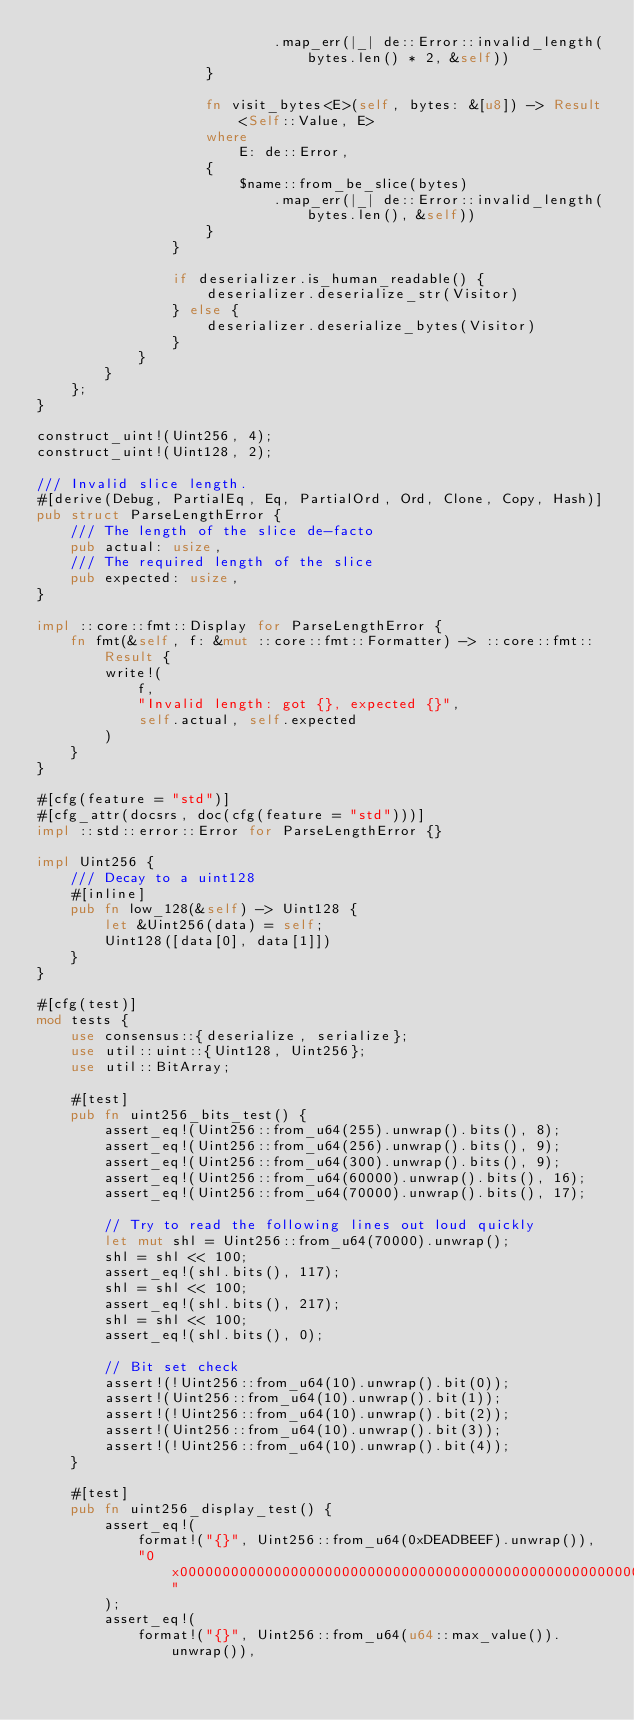<code> <loc_0><loc_0><loc_500><loc_500><_Rust_>                            .map_err(|_| de::Error::invalid_length(bytes.len() * 2, &self))
                    }

                    fn visit_bytes<E>(self, bytes: &[u8]) -> Result<Self::Value, E>
                    where
                        E: de::Error,
                    {
                        $name::from_be_slice(bytes)
                            .map_err(|_| de::Error::invalid_length(bytes.len(), &self))
                    }
                }

                if deserializer.is_human_readable() {
                    deserializer.deserialize_str(Visitor)
                } else {
                    deserializer.deserialize_bytes(Visitor)
                }
            }
        }
    };
}

construct_uint!(Uint256, 4);
construct_uint!(Uint128, 2);

/// Invalid slice length.
#[derive(Debug, PartialEq, Eq, PartialOrd, Ord, Clone, Copy, Hash)]
pub struct ParseLengthError {
    /// The length of the slice de-facto
    pub actual: usize,
    /// The required length of the slice
    pub expected: usize,
}

impl ::core::fmt::Display for ParseLengthError {
    fn fmt(&self, f: &mut ::core::fmt::Formatter) -> ::core::fmt::Result {
        write!(
            f,
            "Invalid length: got {}, expected {}",
            self.actual, self.expected
        )
    }
}

#[cfg(feature = "std")]
#[cfg_attr(docsrs, doc(cfg(feature = "std")))]
impl ::std::error::Error for ParseLengthError {}

impl Uint256 {
    /// Decay to a uint128
    #[inline]
    pub fn low_128(&self) -> Uint128 {
        let &Uint256(data) = self;
        Uint128([data[0], data[1]])
    }
}

#[cfg(test)]
mod tests {
    use consensus::{deserialize, serialize};
    use util::uint::{Uint128, Uint256};
    use util::BitArray;

    #[test]
    pub fn uint256_bits_test() {
        assert_eq!(Uint256::from_u64(255).unwrap().bits(), 8);
        assert_eq!(Uint256::from_u64(256).unwrap().bits(), 9);
        assert_eq!(Uint256::from_u64(300).unwrap().bits(), 9);
        assert_eq!(Uint256::from_u64(60000).unwrap().bits(), 16);
        assert_eq!(Uint256::from_u64(70000).unwrap().bits(), 17);

        // Try to read the following lines out loud quickly
        let mut shl = Uint256::from_u64(70000).unwrap();
        shl = shl << 100;
        assert_eq!(shl.bits(), 117);
        shl = shl << 100;
        assert_eq!(shl.bits(), 217);
        shl = shl << 100;
        assert_eq!(shl.bits(), 0);

        // Bit set check
        assert!(!Uint256::from_u64(10).unwrap().bit(0));
        assert!(Uint256::from_u64(10).unwrap().bit(1));
        assert!(!Uint256::from_u64(10).unwrap().bit(2));
        assert!(Uint256::from_u64(10).unwrap().bit(3));
        assert!(!Uint256::from_u64(10).unwrap().bit(4));
    }

    #[test]
    pub fn uint256_display_test() {
        assert_eq!(
            format!("{}", Uint256::from_u64(0xDEADBEEF).unwrap()),
            "0x00000000000000000000000000000000000000000000000000000000deadbeef"
        );
        assert_eq!(
            format!("{}", Uint256::from_u64(u64::max_value()).unwrap()),</code> 